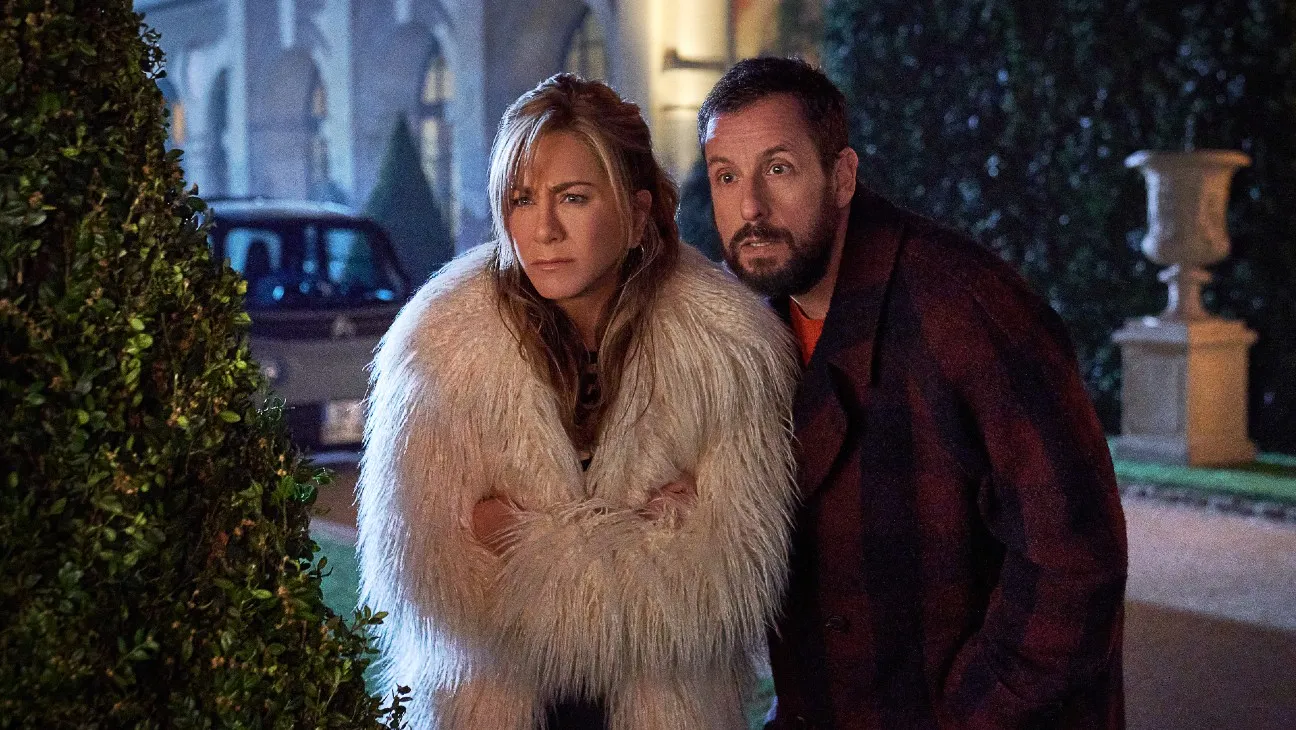What are the possible reasons these two people might be outside on a snowy night? The two individuals could be outside on a snowy night for various reasons such as attending a social event, a pressing engagement that requires their immediate attention, or possibly a scene from a movie where their characters need to resolve a conflict. The formal attire and tense expressions suggest a significant event or moment. 